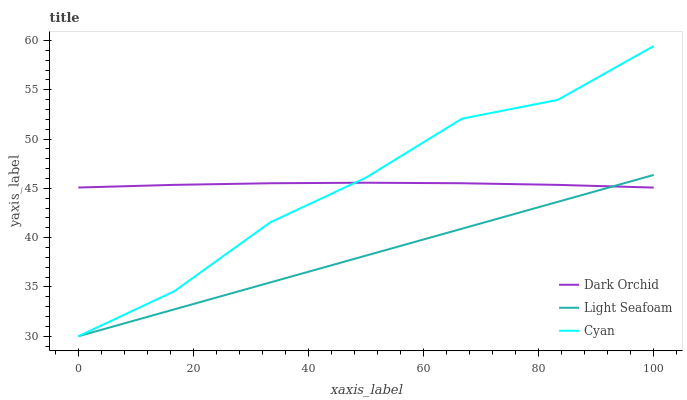Does Dark Orchid have the minimum area under the curve?
Answer yes or no. No. Does Dark Orchid have the maximum area under the curve?
Answer yes or no. No. Is Dark Orchid the smoothest?
Answer yes or no. No. Is Dark Orchid the roughest?
Answer yes or no. No. Does Dark Orchid have the lowest value?
Answer yes or no. No. Does Light Seafoam have the highest value?
Answer yes or no. No. 